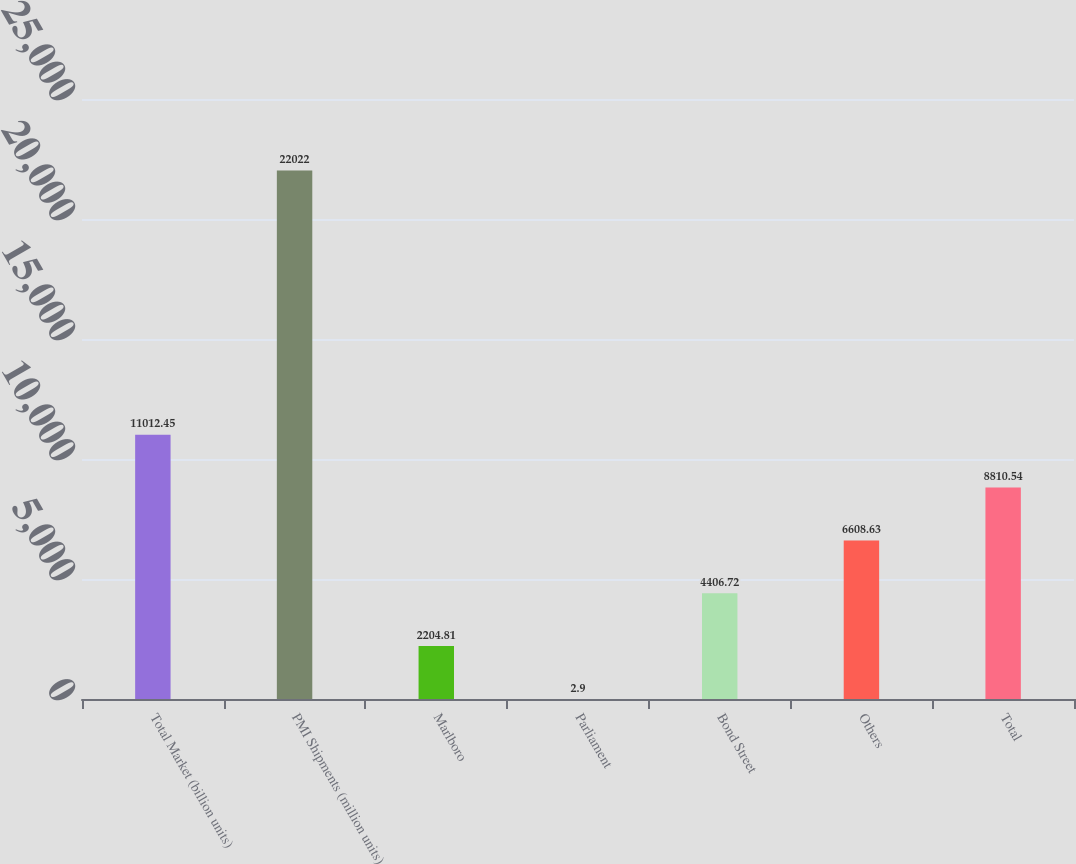<chart> <loc_0><loc_0><loc_500><loc_500><bar_chart><fcel>Total Market (billion units)<fcel>PMI Shipments (million units)<fcel>Marlboro<fcel>Parliament<fcel>Bond Street<fcel>Others<fcel>Total<nl><fcel>11012.5<fcel>22022<fcel>2204.81<fcel>2.9<fcel>4406.72<fcel>6608.63<fcel>8810.54<nl></chart> 